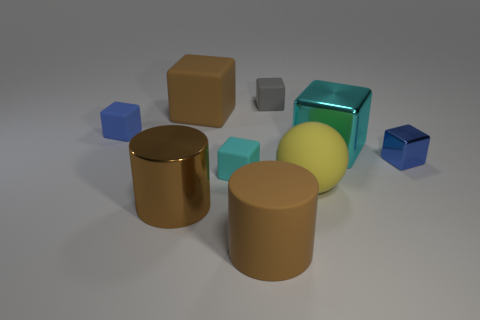There is a big matte block; are there any cyan matte objects right of it?
Keep it short and to the point. Yes. The rubber sphere has what color?
Offer a very short reply. Yellow. Does the big matte block have the same color as the big rubber cylinder on the left side of the big cyan metal thing?
Make the answer very short. Yes. Are there any other rubber things of the same size as the yellow thing?
Your answer should be very brief. Yes. What size is the rubber cylinder that is the same color as the shiny cylinder?
Offer a very short reply. Large. What is the material of the yellow ball in front of the large metal block?
Give a very brief answer. Rubber. Are there the same number of small cyan rubber objects that are on the right side of the small cyan cube and cyan objects that are left of the sphere?
Offer a very short reply. No. Does the rubber cylinder to the right of the large brown shiny thing have the same size as the cyan thing that is on the left side of the tiny gray rubber thing?
Provide a succinct answer. No. How many things are the same color as the large matte ball?
Give a very brief answer. 0. What is the material of the other big cylinder that is the same color as the big matte cylinder?
Your answer should be very brief. Metal. 